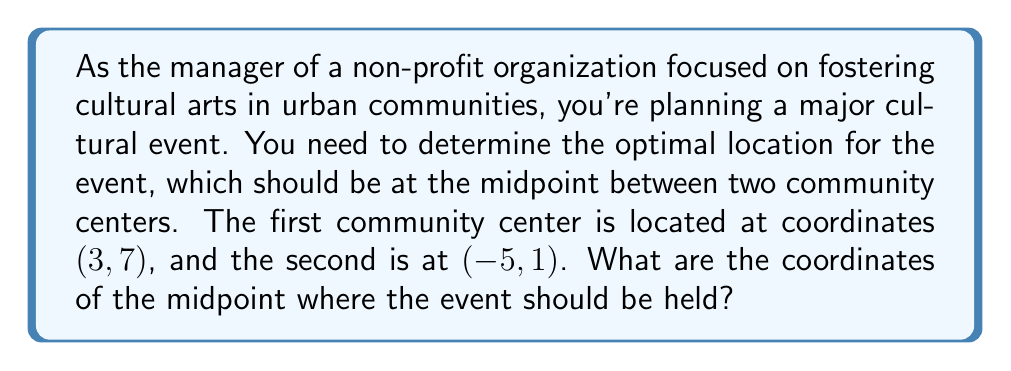Give your solution to this math problem. To find the midpoint between two points in a coordinate system, we use the midpoint formula:

$$ \text{Midpoint} = \left(\frac{x_1 + x_2}{2}, \frac{y_1 + y_2}{2}\right) $$

Where $(x_1, y_1)$ are the coordinates of the first point and $(x_2, y_2)$ are the coordinates of the second point.

Let's identify our points:
- Community Center 1: $(x_1, y_1) = (3, 7)$
- Community Center 2: $(x_2, y_2) = (-5, 1)$

Now, let's apply the midpoint formula:

For the x-coordinate:
$$ \frac{x_1 + x_2}{2} = \frac{3 + (-5)}{2} = \frac{-2}{2} = -1 $$

For the y-coordinate:
$$ \frac{y_1 + y_2}{2} = \frac{7 + 1}{2} = \frac{8}{2} = 4 $$

Therefore, the midpoint coordinates are $(-1, 4)$.

[asy]
import graph;
size(200);
xaxis("x",-6,4,arrow=Arrow);
yaxis("y",-1,8,arrow=Arrow);
dot((3,7),red);
dot((-5,1),red);
dot((-1,4),blue);
label("(3, 7)",(3,7),NE,red);
label("(-5, 1)",(-5,1),SW,red);
label("(-1, 4)",(-1,4),SE,blue);
draw((3,7)--(-5,1),dashed);
[/asy]
Answer: The optimal location for the cultural event should be at coordinates $(-1, 4)$. 